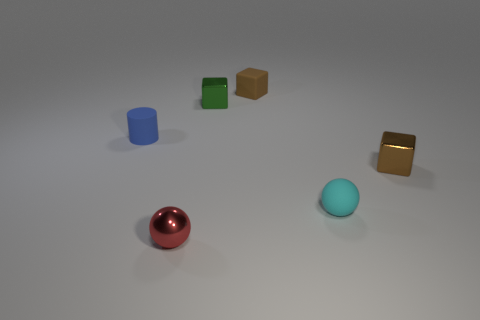Add 2 big purple matte balls. How many objects exist? 8 Subtract all cylinders. How many objects are left? 5 Add 3 tiny shiny objects. How many tiny shiny objects exist? 6 Subtract 0 red cubes. How many objects are left? 6 Subtract all tiny matte objects. Subtract all brown blocks. How many objects are left? 1 Add 2 green shiny cubes. How many green shiny cubes are left? 3 